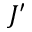<formula> <loc_0><loc_0><loc_500><loc_500>J ^ { \prime }</formula> 